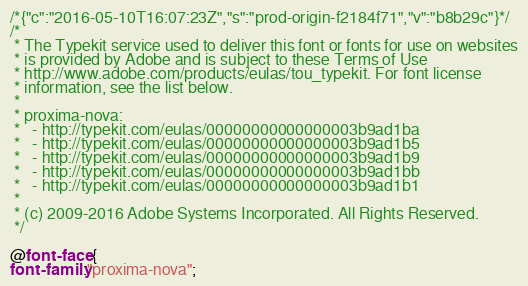<code> <loc_0><loc_0><loc_500><loc_500><_CSS_>/*{"c":"2016-05-10T16:07:23Z","s":"prod-origin-f2184f71","v":"b8b29c"}*/
/*
 * The Typekit service used to deliver this font or fonts for use on websites
 * is provided by Adobe and is subject to these Terms of Use
 * http://www.adobe.com/products/eulas/tou_typekit. For font license
 * information, see the list below.
 *
 * proxima-nova:
 *   - http://typekit.com/eulas/00000000000000003b9ad1ba
 *   - http://typekit.com/eulas/00000000000000003b9ad1b5
 *   - http://typekit.com/eulas/00000000000000003b9ad1b9
 *   - http://typekit.com/eulas/00000000000000003b9ad1bb
 *   - http://typekit.com/eulas/00000000000000003b9ad1b1
 *
 * (c) 2009-2016 Adobe Systems Incorporated. All Rights Reserved.
 */

@font-face {
font-family:"proxima-nova";</code> 